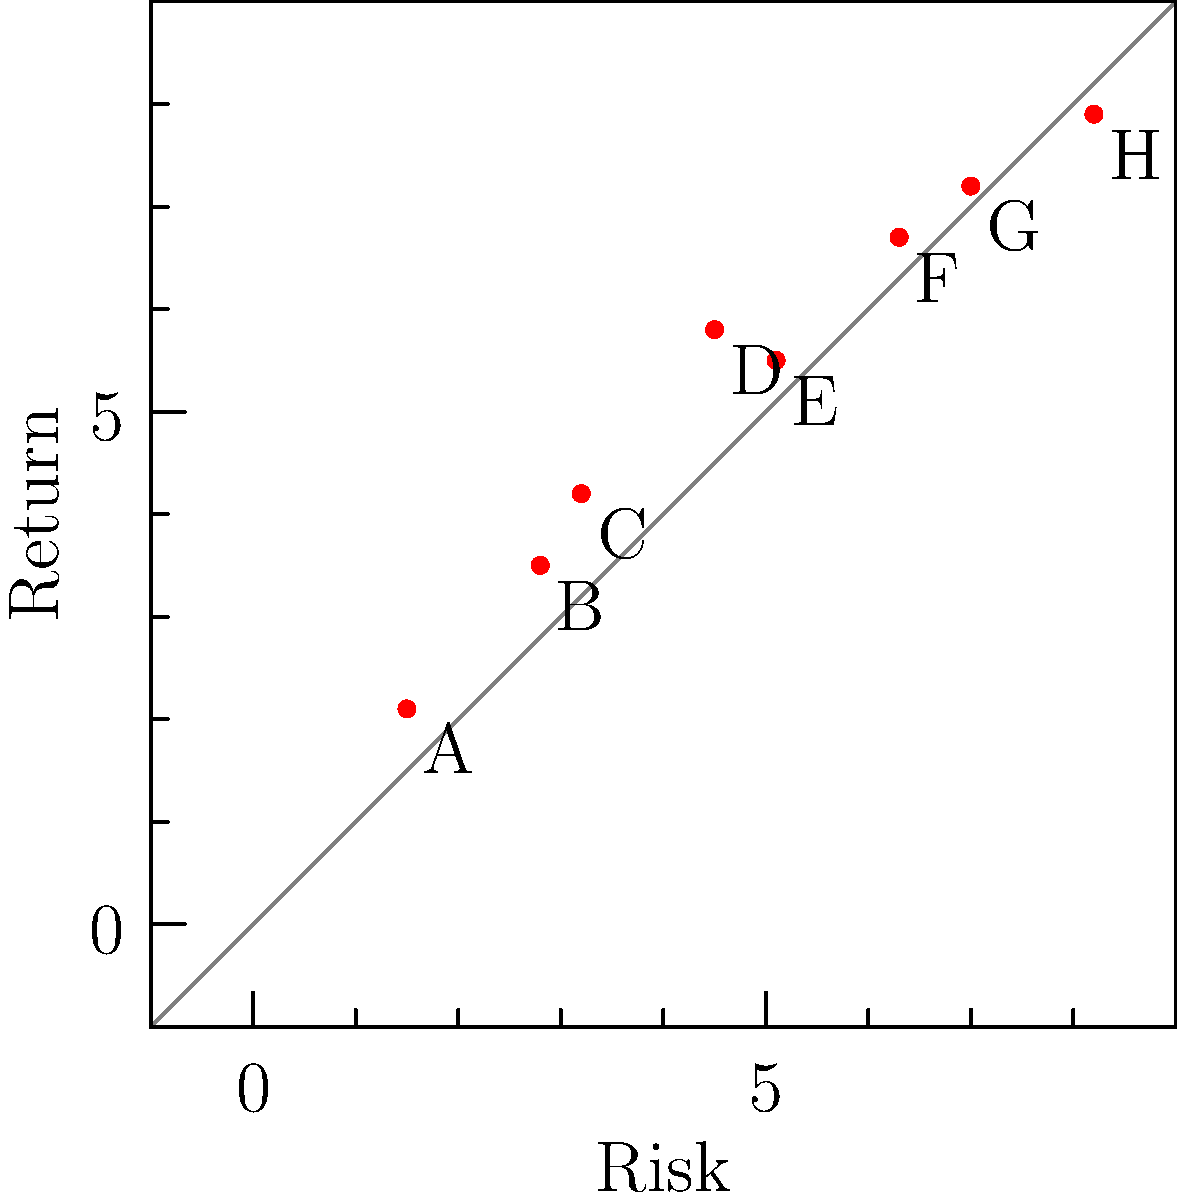As a trust fund manager prioritizing long-term stability, which investment option would you likely choose based on the scatter plot of risk versus return for various investments (labeled A through H)? To answer this question, we need to analyze the scatter plot and consider the priorities of a trust fund manager focused on long-term stability. Let's break it down step-by-step:

1. Understand the plot:
   - The x-axis represents risk (higher values = higher risk)
   - The y-axis represents return (higher values = higher return)
   - Each point (A through H) represents a different investment option

2. Consider the manager's priorities:
   - Long-term stability is the main focus
   - Short-term gains are less important

3. Analyze the investment options:
   - Options with lower risk are generally more stable
   - We want a balance of low risk and reasonable return

4. Compare the options:
   - A: Lowest risk, but also lowest return
   - B and C: Low risk with slightly better returns
   - D: Moderate risk with good return
   - E, F, G, H: Higher risk options, not ideal for stability

5. Choose the best option:
   - B or C would be the most suitable choices
   - C offers a slightly better return than B with only a small increase in risk

6. Final decision:
   - Option C provides the best balance of low risk and reasonable return, aligning with the goal of long-term stability

Therefore, a trust fund manager prioritizing long-term stability would likely choose investment option C.
Answer: C 